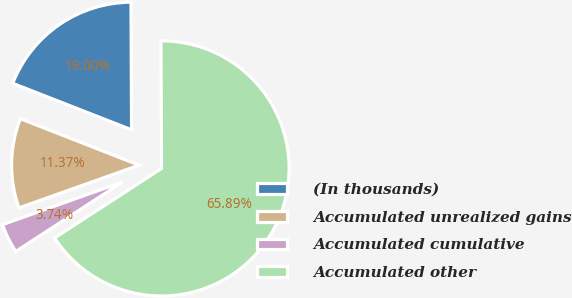<chart> <loc_0><loc_0><loc_500><loc_500><pie_chart><fcel>(In thousands)<fcel>Accumulated unrealized gains<fcel>Accumulated cumulative<fcel>Accumulated other<nl><fcel>19.0%<fcel>11.37%<fcel>3.74%<fcel>65.9%<nl></chart> 